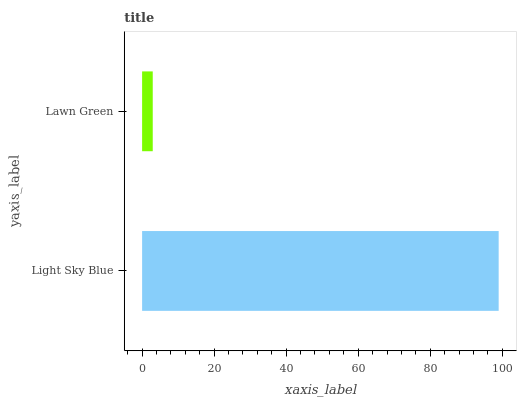Is Lawn Green the minimum?
Answer yes or no. Yes. Is Light Sky Blue the maximum?
Answer yes or no. Yes. Is Lawn Green the maximum?
Answer yes or no. No. Is Light Sky Blue greater than Lawn Green?
Answer yes or no. Yes. Is Lawn Green less than Light Sky Blue?
Answer yes or no. Yes. Is Lawn Green greater than Light Sky Blue?
Answer yes or no. No. Is Light Sky Blue less than Lawn Green?
Answer yes or no. No. Is Light Sky Blue the high median?
Answer yes or no. Yes. Is Lawn Green the low median?
Answer yes or no. Yes. Is Lawn Green the high median?
Answer yes or no. No. Is Light Sky Blue the low median?
Answer yes or no. No. 